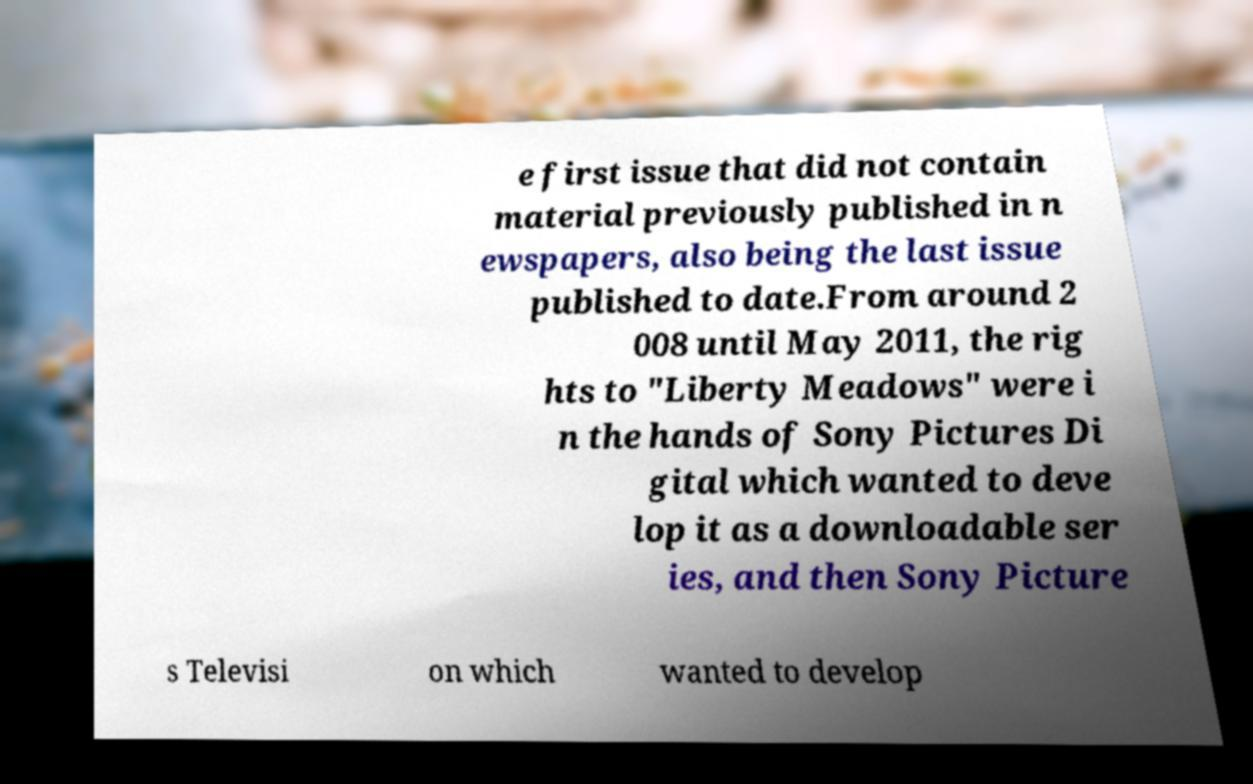For documentation purposes, I need the text within this image transcribed. Could you provide that? e first issue that did not contain material previously published in n ewspapers, also being the last issue published to date.From around 2 008 until May 2011, the rig hts to "Liberty Meadows" were i n the hands of Sony Pictures Di gital which wanted to deve lop it as a downloadable ser ies, and then Sony Picture s Televisi on which wanted to develop 